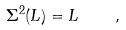<formula> <loc_0><loc_0><loc_500><loc_500>\Sigma ^ { 2 } ( L ) = L \quad ,</formula> 